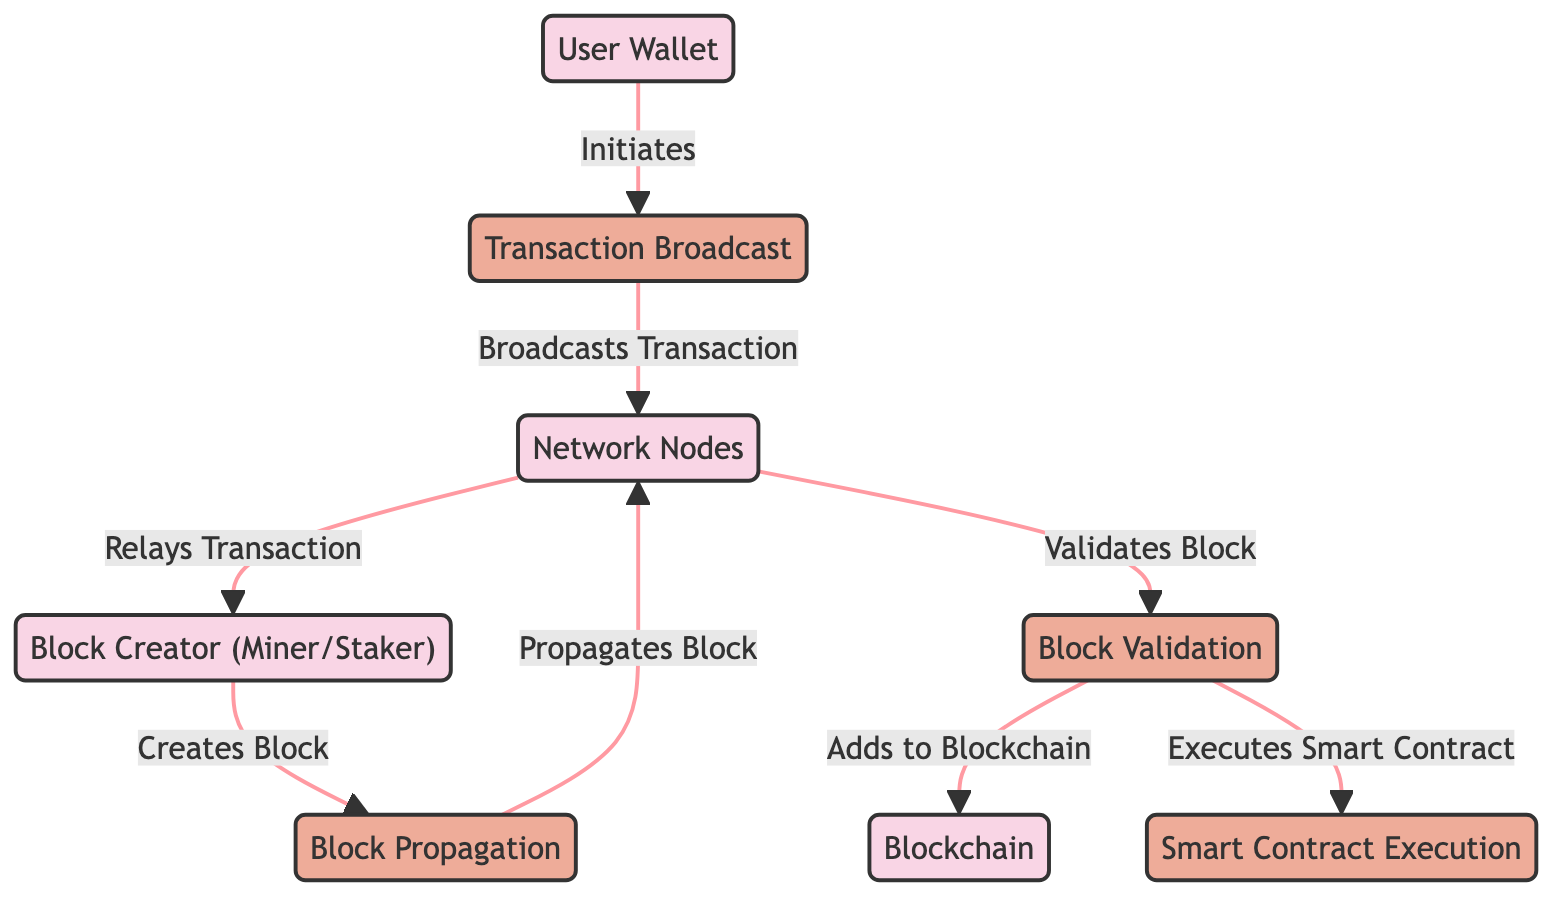What is the first step initiated by the user? The diagram shows that the first action taken by the user is to initiate a transaction broadcast from the User Wallet.
Answer: Transaction Broadcast How many entities are present in the diagram? The diagram lists a total of four entities: User Wallet, Network Nodes, Block Creator (Miner/Staker), and Blockchain.
Answer: Four What does the Block Creator do after relaying the transaction? According to the diagram, after relaying the transaction, the Block Creator creates a block.
Answer: Creates Block What process follows the Block Propagation in the diagram? After the Block Propagation occurs, the next process is Block Validation carried out by the Network Nodes.
Answer: Block Validation Which process executes smart contracts? The diagram indicates that smart contract execution takes place as part of the Block Validation process.
Answer: Block Validation How many relationships are shown between nodes? The diagram contains a total of seven relationships (edges) connecting the nodes.
Answer: Seven What action is performed by the Network Nodes after receiving a new block? The Network Nodes validate the new block after it is propagated through the network.
Answer: Validates Block What is the final step in the transaction flow shown in the diagram? The final step illustrates that the block validation process adds the validated blocks to the blockchain.
Answer: Adds to Blockchain Which entity is responsible for creating new blocks? The Block Creator (Miner/Staker) is identified as the entity responsible for creating new blocks in the diagram.
Answer: Block Creator (Miner/Staker) 